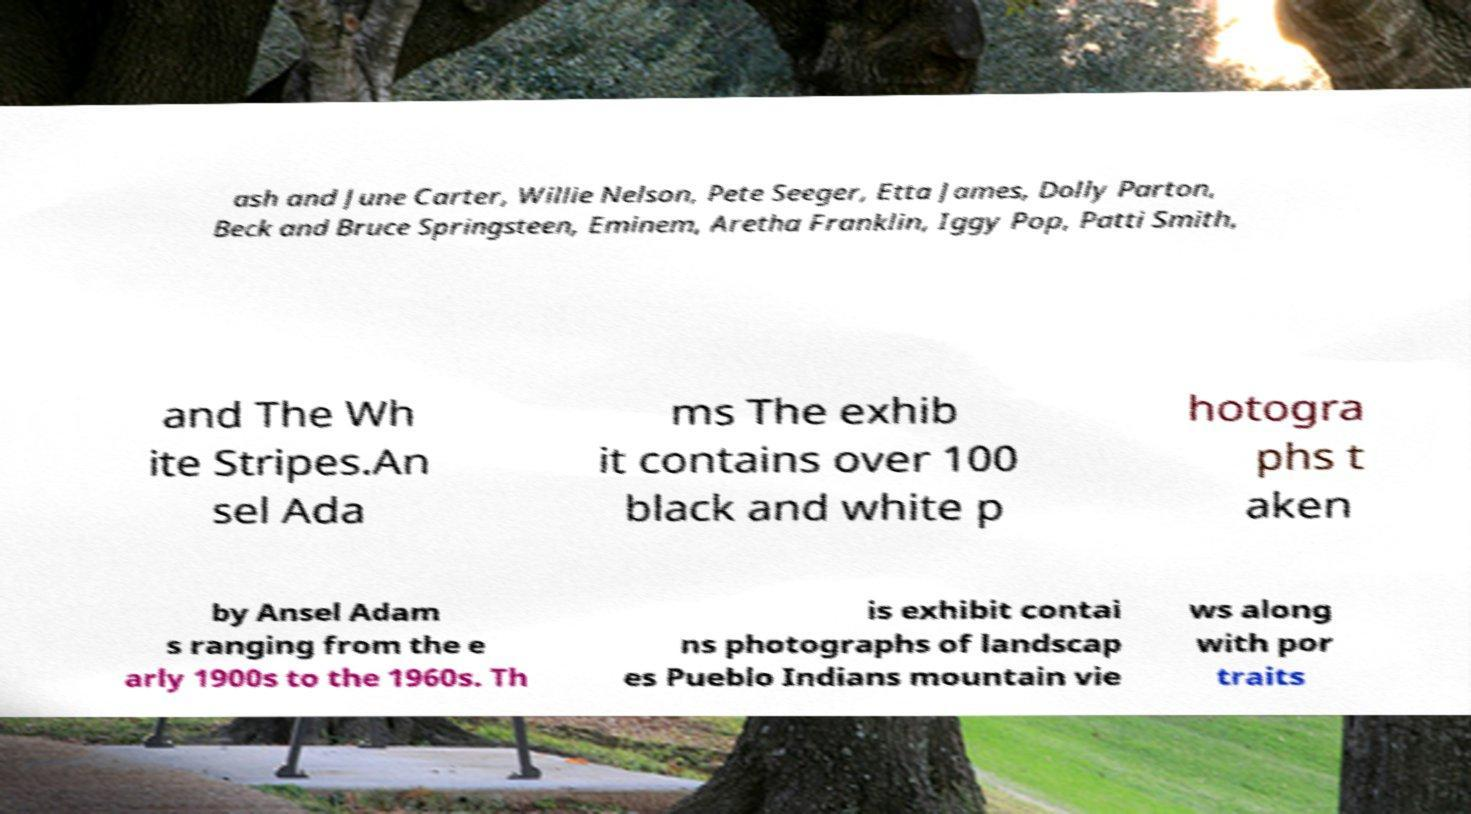Can you accurately transcribe the text from the provided image for me? ash and June Carter, Willie Nelson, Pete Seeger, Etta James, Dolly Parton, Beck and Bruce Springsteen, Eminem, Aretha Franklin, Iggy Pop, Patti Smith, and The Wh ite Stripes.An sel Ada ms The exhib it contains over 100 black and white p hotogra phs t aken by Ansel Adam s ranging from the e arly 1900s to the 1960s. Th is exhibit contai ns photographs of landscap es Pueblo Indians mountain vie ws along with por traits 